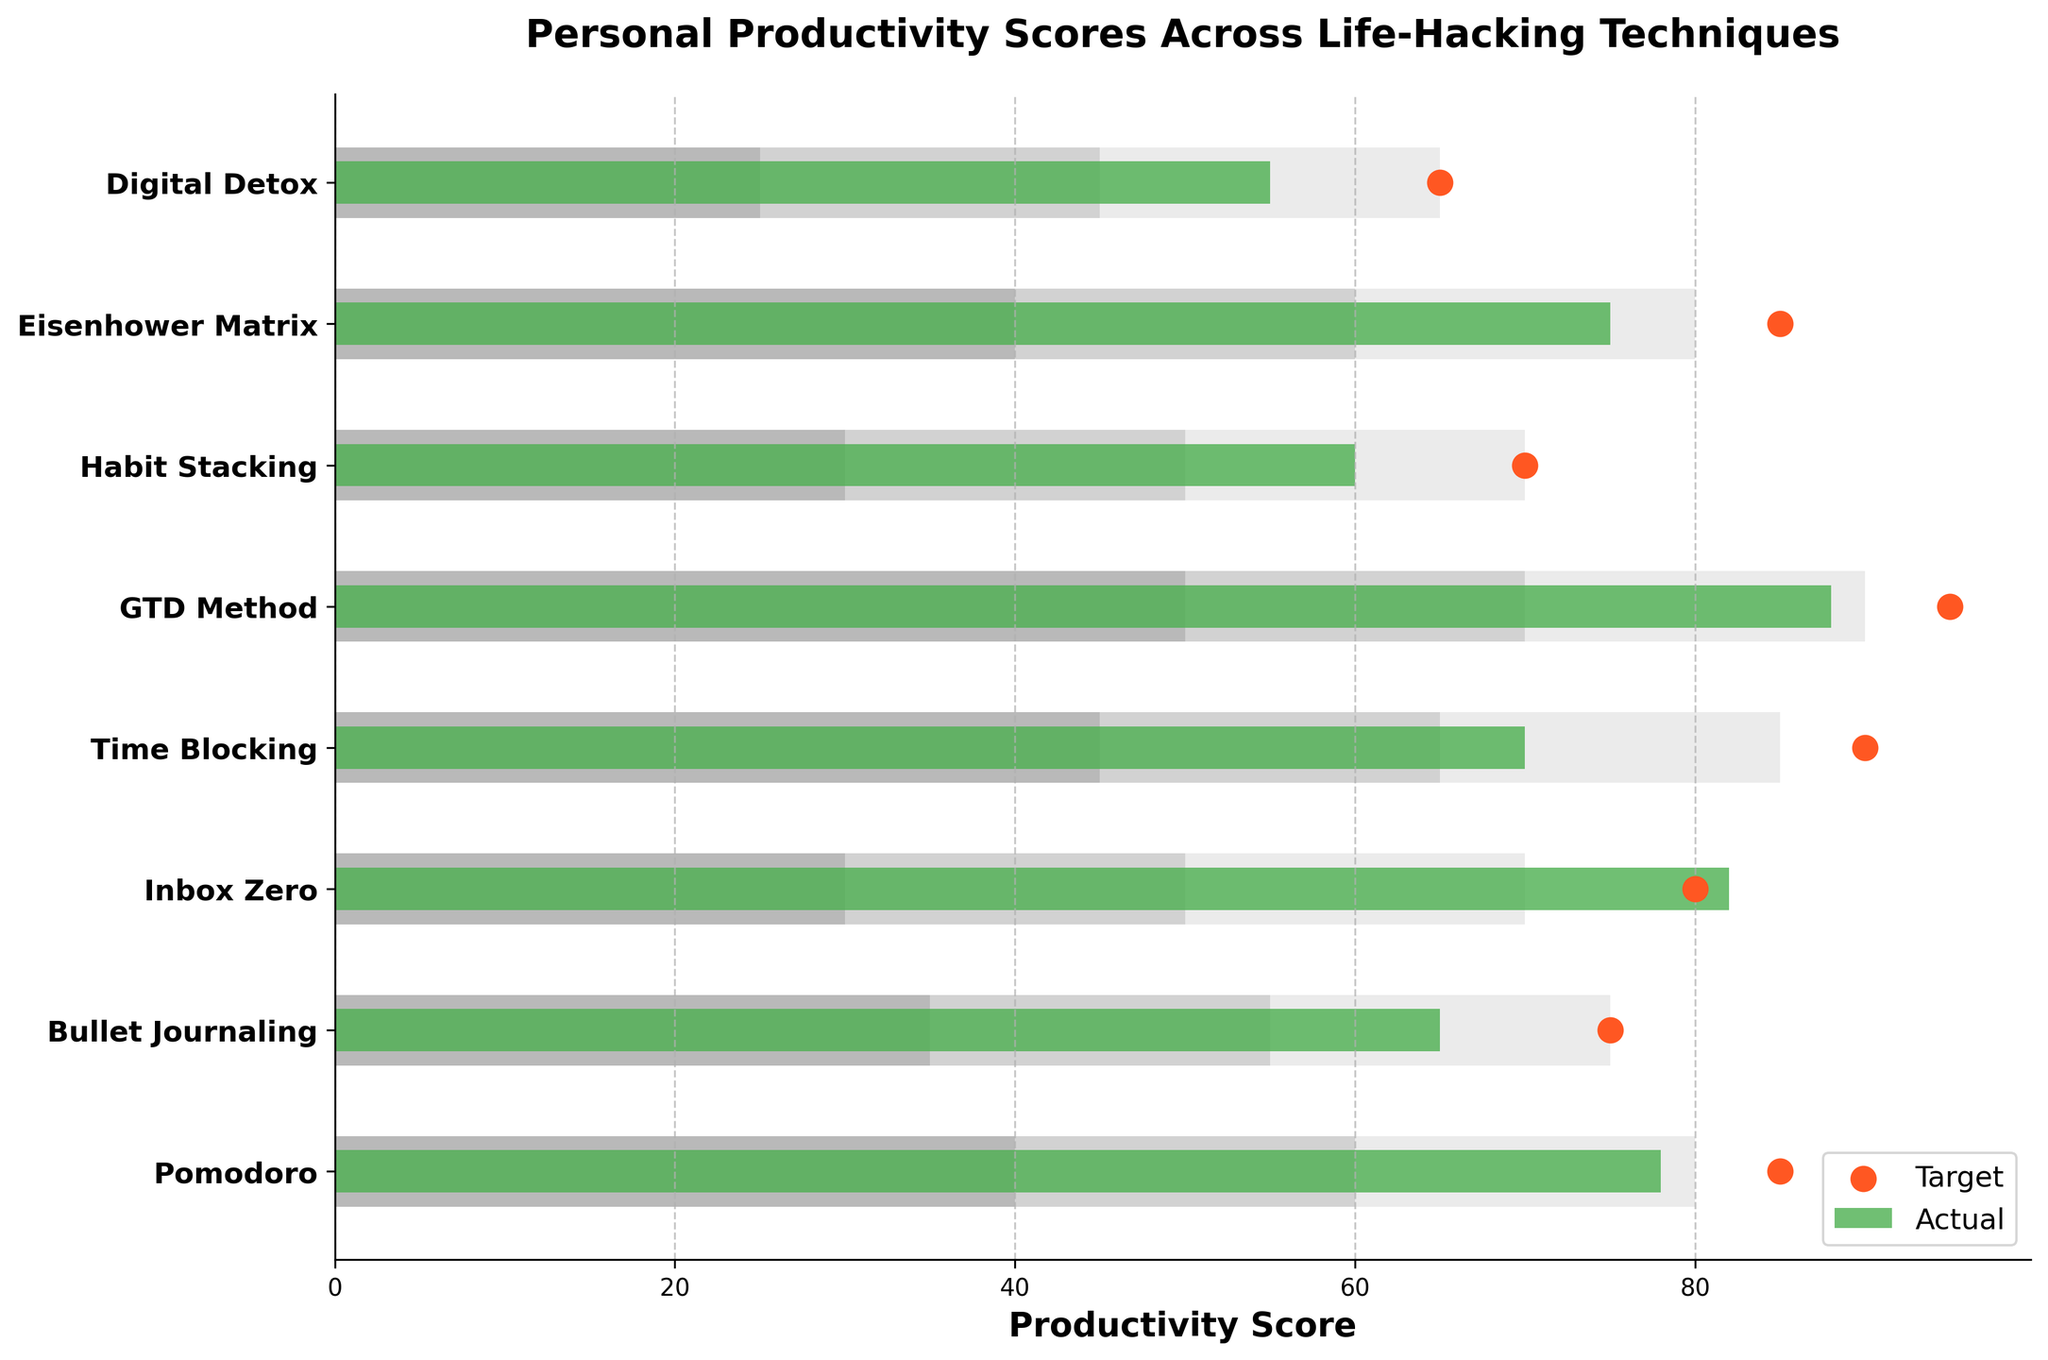What's the title of the chart? The title of the chart is usually at the top and provides a brief summary of the chart's content. In this case, it is "Personal Productivity Scores Across Life-Hacking Techniques"
Answer: Personal Productivity Scores Across Life-Hacking Techniques What techniques have their actual productivity scores higher than their target? To answer this, compare the actual and target scores for each technique. Techniques where the actual score is higher than the target are: Pomodoro, Bullet Journaling, Inbox Zero, Habit Stacking, and Eisenhower Matrix.
Answer: Pomodoro, Bullet Journaling, Inbox Zero, Habit Stacking, Eisenhower Matrix Which technique has the highest actual productivity score? By visually scanning the actual scores, the highest bar represents the technique with the highest actual productivity score. The GTD Method has the highest actual score of 88.
Answer: GTD Method Which techniques have an "Actual" score within the "Medium" range? The "Medium" range is provided for each technique; cross-check if the actual score falls within this range. The applicable techniques are Pomodoro, Bullet Journaling, Inbox Zero, Eisenhower Matrix, and Digital Detox.
Answer: Pomodoro, Bullet Journaling, Inbox Zero, Eisenhower Matrix, Digital Detox What is the average target score across all techniques? Sum the target scores and divide by the number of techniques. The target scores are (85 + 75 + 80 + 90 + 95 + 70 + 85 + 65) = 645. There are 8 techniques. The average is 645 / 8 = 80.625.
Answer: 80.625 Which techniques fell short of their high productivity target? The high productivity target for each technique is listed under 'High.' Check if the actual score is less than this value. All techniques except GTD Method failed to meet their high target.
Answer: All except GTD Method What is the absolute difference between the actual and target scores for the Time Blocking technique? For Time Blocking, the actual score is 70, and the target score is 90. The difference is
Answer: 20 